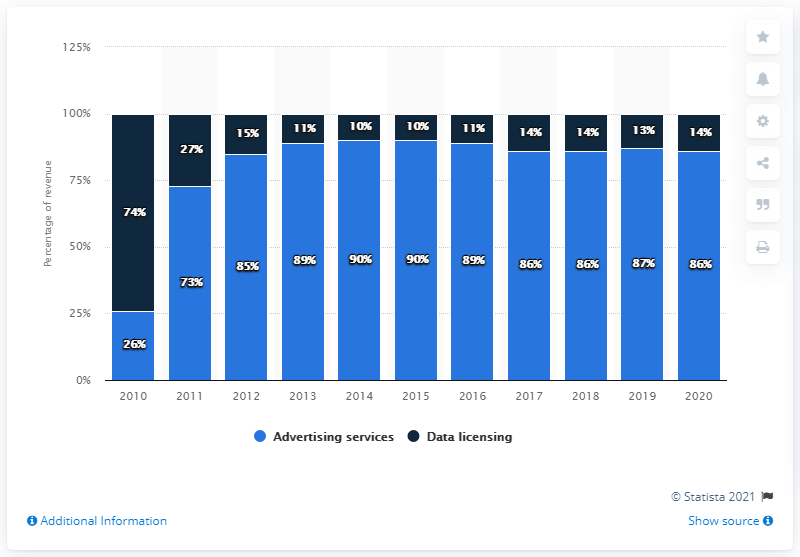Mention a couple of crucial points in this snapshot. The average of the last three years in Advertising services is 86.33. In 2010, data licensing accounted for approximately 74% of the overall value of the data industry. 